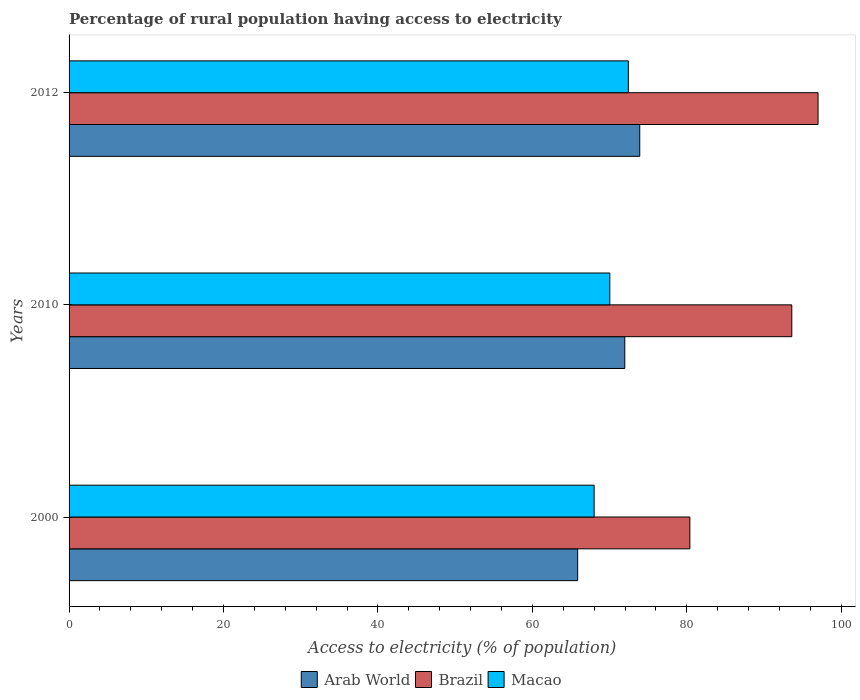How many groups of bars are there?
Make the answer very short. 3. Are the number of bars on each tick of the Y-axis equal?
Your answer should be very brief. Yes. How many bars are there on the 3rd tick from the top?
Offer a terse response. 3. What is the percentage of rural population having access to electricity in Arab World in 2012?
Your answer should be very brief. 73.91. Across all years, what is the maximum percentage of rural population having access to electricity in Macao?
Your answer should be very brief. 72.43. Across all years, what is the minimum percentage of rural population having access to electricity in Brazil?
Provide a short and direct response. 80.4. What is the total percentage of rural population having access to electricity in Brazil in the graph?
Your response must be concise. 271. What is the difference between the percentage of rural population having access to electricity in Arab World in 2000 and that in 2010?
Provide a succinct answer. -6.1. What is the difference between the percentage of rural population having access to electricity in Brazil in 2010 and the percentage of rural population having access to electricity in Arab World in 2000?
Keep it short and to the point. 27.73. What is the average percentage of rural population having access to electricity in Arab World per year?
Offer a very short reply. 70.58. In the year 2012, what is the difference between the percentage of rural population having access to electricity in Macao and percentage of rural population having access to electricity in Brazil?
Provide a short and direct response. -24.57. What is the ratio of the percentage of rural population having access to electricity in Brazil in 2000 to that in 2010?
Give a very brief answer. 0.86. Is the percentage of rural population having access to electricity in Brazil in 2000 less than that in 2010?
Ensure brevity in your answer.  Yes. Is the difference between the percentage of rural population having access to electricity in Macao in 2010 and 2012 greater than the difference between the percentage of rural population having access to electricity in Brazil in 2010 and 2012?
Offer a terse response. Yes. What is the difference between the highest and the second highest percentage of rural population having access to electricity in Brazil?
Give a very brief answer. 3.4. What is the difference between the highest and the lowest percentage of rural population having access to electricity in Macao?
Provide a short and direct response. 4.43. What does the 3rd bar from the top in 2012 represents?
Make the answer very short. Arab World. What does the 3rd bar from the bottom in 2010 represents?
Provide a short and direct response. Macao. Are all the bars in the graph horizontal?
Your answer should be compact. Yes. How many years are there in the graph?
Give a very brief answer. 3. Where does the legend appear in the graph?
Keep it short and to the point. Bottom center. How many legend labels are there?
Ensure brevity in your answer.  3. What is the title of the graph?
Provide a succinct answer. Percentage of rural population having access to electricity. What is the label or title of the X-axis?
Ensure brevity in your answer.  Access to electricity (% of population). What is the Access to electricity (% of population) of Arab World in 2000?
Your answer should be compact. 65.87. What is the Access to electricity (% of population) of Brazil in 2000?
Your response must be concise. 80.4. What is the Access to electricity (% of population) in Arab World in 2010?
Offer a terse response. 71.97. What is the Access to electricity (% of population) of Brazil in 2010?
Keep it short and to the point. 93.6. What is the Access to electricity (% of population) in Macao in 2010?
Make the answer very short. 70.03. What is the Access to electricity (% of population) in Arab World in 2012?
Give a very brief answer. 73.91. What is the Access to electricity (% of population) in Brazil in 2012?
Ensure brevity in your answer.  97. What is the Access to electricity (% of population) in Macao in 2012?
Make the answer very short. 72.43. Across all years, what is the maximum Access to electricity (% of population) in Arab World?
Offer a very short reply. 73.91. Across all years, what is the maximum Access to electricity (% of population) of Brazil?
Offer a very short reply. 97. Across all years, what is the maximum Access to electricity (% of population) of Macao?
Provide a short and direct response. 72.43. Across all years, what is the minimum Access to electricity (% of population) in Arab World?
Your answer should be very brief. 65.87. Across all years, what is the minimum Access to electricity (% of population) in Brazil?
Your answer should be compact. 80.4. What is the total Access to electricity (% of population) of Arab World in the graph?
Offer a very short reply. 211.75. What is the total Access to electricity (% of population) in Brazil in the graph?
Ensure brevity in your answer.  271. What is the total Access to electricity (% of population) of Macao in the graph?
Your answer should be very brief. 210.47. What is the difference between the Access to electricity (% of population) in Arab World in 2000 and that in 2010?
Keep it short and to the point. -6.1. What is the difference between the Access to electricity (% of population) in Macao in 2000 and that in 2010?
Ensure brevity in your answer.  -2.03. What is the difference between the Access to electricity (% of population) of Arab World in 2000 and that in 2012?
Make the answer very short. -8.04. What is the difference between the Access to electricity (% of population) in Brazil in 2000 and that in 2012?
Provide a succinct answer. -16.6. What is the difference between the Access to electricity (% of population) in Macao in 2000 and that in 2012?
Ensure brevity in your answer.  -4.43. What is the difference between the Access to electricity (% of population) of Arab World in 2010 and that in 2012?
Your answer should be very brief. -1.94. What is the difference between the Access to electricity (% of population) in Brazil in 2010 and that in 2012?
Make the answer very short. -3.4. What is the difference between the Access to electricity (% of population) in Macao in 2010 and that in 2012?
Give a very brief answer. -2.4. What is the difference between the Access to electricity (% of population) in Arab World in 2000 and the Access to electricity (% of population) in Brazil in 2010?
Make the answer very short. -27.73. What is the difference between the Access to electricity (% of population) in Arab World in 2000 and the Access to electricity (% of population) in Macao in 2010?
Give a very brief answer. -4.16. What is the difference between the Access to electricity (% of population) of Brazil in 2000 and the Access to electricity (% of population) of Macao in 2010?
Give a very brief answer. 10.37. What is the difference between the Access to electricity (% of population) of Arab World in 2000 and the Access to electricity (% of population) of Brazil in 2012?
Offer a very short reply. -31.13. What is the difference between the Access to electricity (% of population) in Arab World in 2000 and the Access to electricity (% of population) in Macao in 2012?
Ensure brevity in your answer.  -6.57. What is the difference between the Access to electricity (% of population) in Brazil in 2000 and the Access to electricity (% of population) in Macao in 2012?
Provide a succinct answer. 7.97. What is the difference between the Access to electricity (% of population) in Arab World in 2010 and the Access to electricity (% of population) in Brazil in 2012?
Offer a very short reply. -25.03. What is the difference between the Access to electricity (% of population) in Arab World in 2010 and the Access to electricity (% of population) in Macao in 2012?
Ensure brevity in your answer.  -0.46. What is the difference between the Access to electricity (% of population) of Brazil in 2010 and the Access to electricity (% of population) of Macao in 2012?
Offer a very short reply. 21.17. What is the average Access to electricity (% of population) in Arab World per year?
Give a very brief answer. 70.58. What is the average Access to electricity (% of population) of Brazil per year?
Give a very brief answer. 90.33. What is the average Access to electricity (% of population) in Macao per year?
Make the answer very short. 70.16. In the year 2000, what is the difference between the Access to electricity (% of population) in Arab World and Access to electricity (% of population) in Brazil?
Give a very brief answer. -14.53. In the year 2000, what is the difference between the Access to electricity (% of population) in Arab World and Access to electricity (% of population) in Macao?
Offer a terse response. -2.13. In the year 2010, what is the difference between the Access to electricity (% of population) in Arab World and Access to electricity (% of population) in Brazil?
Offer a very short reply. -21.63. In the year 2010, what is the difference between the Access to electricity (% of population) of Arab World and Access to electricity (% of population) of Macao?
Your answer should be compact. 1.94. In the year 2010, what is the difference between the Access to electricity (% of population) of Brazil and Access to electricity (% of population) of Macao?
Your answer should be very brief. 23.57. In the year 2012, what is the difference between the Access to electricity (% of population) of Arab World and Access to electricity (% of population) of Brazil?
Your response must be concise. -23.09. In the year 2012, what is the difference between the Access to electricity (% of population) of Arab World and Access to electricity (% of population) of Macao?
Keep it short and to the point. 1.48. In the year 2012, what is the difference between the Access to electricity (% of population) of Brazil and Access to electricity (% of population) of Macao?
Provide a succinct answer. 24.57. What is the ratio of the Access to electricity (% of population) in Arab World in 2000 to that in 2010?
Your answer should be compact. 0.92. What is the ratio of the Access to electricity (% of population) in Brazil in 2000 to that in 2010?
Make the answer very short. 0.86. What is the ratio of the Access to electricity (% of population) in Arab World in 2000 to that in 2012?
Your answer should be compact. 0.89. What is the ratio of the Access to electricity (% of population) of Brazil in 2000 to that in 2012?
Your answer should be compact. 0.83. What is the ratio of the Access to electricity (% of population) of Macao in 2000 to that in 2012?
Your answer should be compact. 0.94. What is the ratio of the Access to electricity (% of population) in Arab World in 2010 to that in 2012?
Your response must be concise. 0.97. What is the ratio of the Access to electricity (% of population) of Brazil in 2010 to that in 2012?
Offer a very short reply. 0.96. What is the ratio of the Access to electricity (% of population) in Macao in 2010 to that in 2012?
Provide a succinct answer. 0.97. What is the difference between the highest and the second highest Access to electricity (% of population) in Arab World?
Make the answer very short. 1.94. What is the difference between the highest and the second highest Access to electricity (% of population) of Macao?
Ensure brevity in your answer.  2.4. What is the difference between the highest and the lowest Access to electricity (% of population) in Arab World?
Offer a very short reply. 8.04. What is the difference between the highest and the lowest Access to electricity (% of population) in Macao?
Provide a short and direct response. 4.43. 